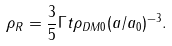<formula> <loc_0><loc_0><loc_500><loc_500>\rho _ { R } = \frac { 3 } { 5 } \Gamma t \rho _ { D M 0 } ( a / a _ { 0 } ) ^ { - 3 } .</formula> 